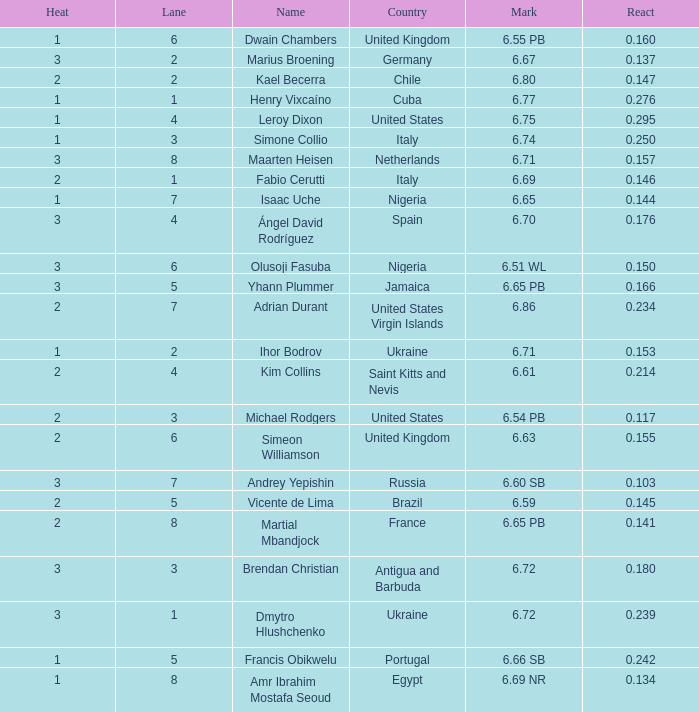What is Mark, when Name is Dmytro Hlushchenko? 6.72. 